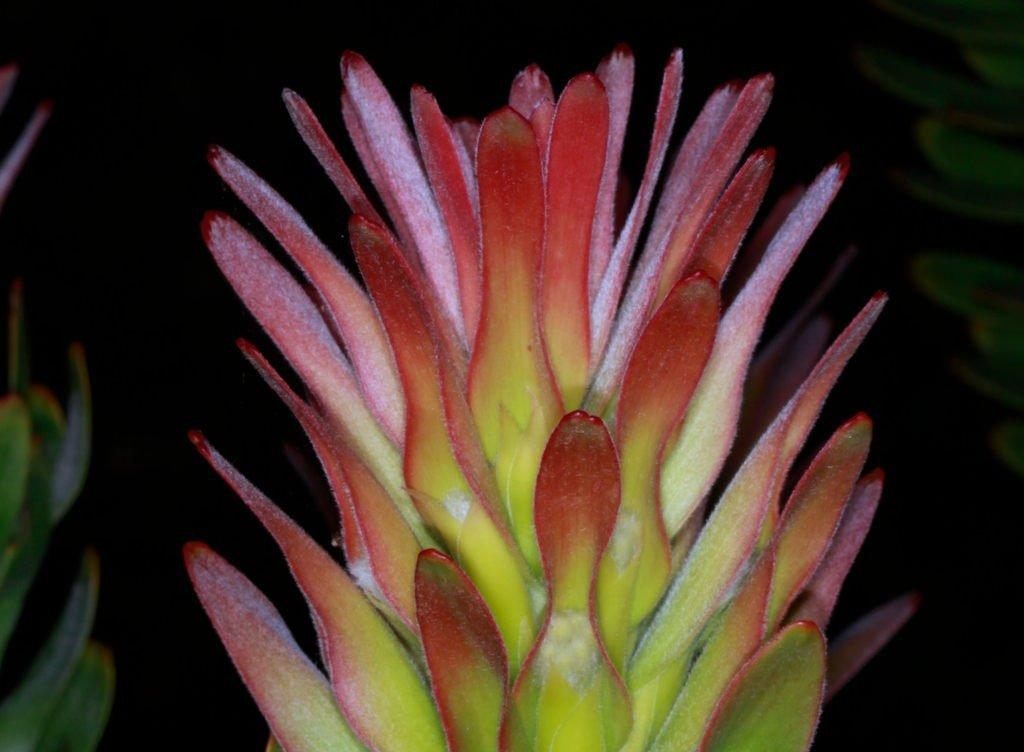What colors can be seen on the leaves in the image? The leaves in the image have green and red colors. How would you describe the overall lighting in the image? The background of the image is dark. What type of marble is used to create the club in the image? There is no marble or club present in the image; it features leaves with green and red colors against a dark background. 